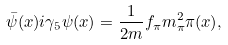<formula> <loc_0><loc_0><loc_500><loc_500>\bar { \psi } ( x ) i \gamma _ { 5 } \psi ( x ) = \frac { 1 } { 2 m } f _ { \pi } m _ { \pi } ^ { 2 } \pi ( x ) ,</formula> 